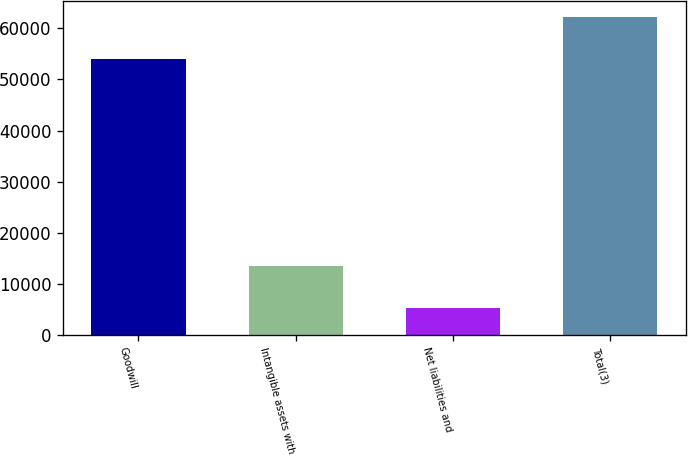Convert chart to OTSL. <chart><loc_0><loc_0><loc_500><loc_500><bar_chart><fcel>Goodwill<fcel>Intangible assets with<fcel>Net liabilities and<fcel>Total(3)<nl><fcel>54008<fcel>13359<fcel>5138<fcel>62229<nl></chart> 